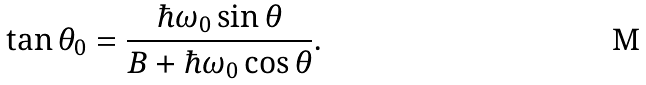Convert formula to latex. <formula><loc_0><loc_0><loc_500><loc_500>\tan \theta _ { 0 } = \frac { \hbar { \omega } _ { 0 } \sin \theta } { B + \hbar { \omega } _ { 0 } \cos \theta } .</formula> 